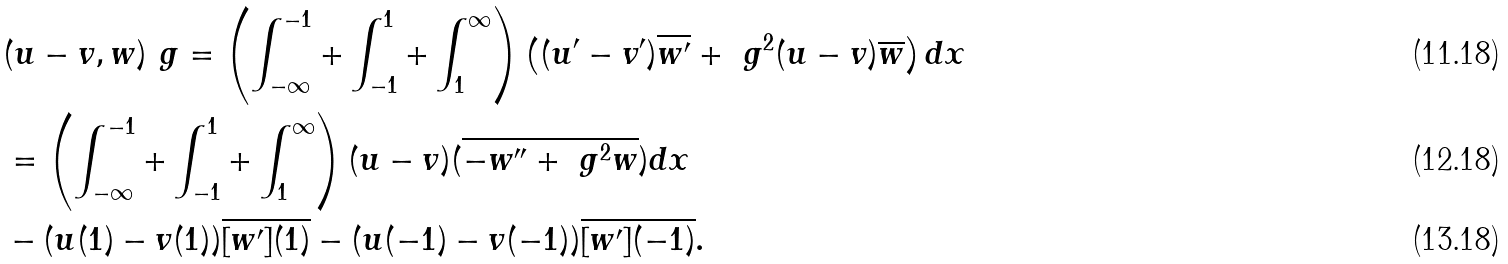Convert formula to latex. <formula><loc_0><loc_0><loc_500><loc_500>& ( u - v , w ) _ { \ } g = \left ( \int _ { - \infty } ^ { - 1 } + \int _ { - 1 } ^ { 1 } + \int _ { 1 } ^ { \infty } \right ) \left ( ( u ^ { \prime } - v ^ { \prime } ) \overline { w ^ { \prime } } + \ g ^ { 2 } ( u - v ) \overline { w } \right ) d x \\ & = \left ( \int _ { - \infty } ^ { - 1 } + \int _ { - 1 } ^ { 1 } + \int _ { 1 } ^ { \infty } \right ) ( u - v ) ( \overline { - w ^ { \prime \prime } + \ g ^ { 2 } { w } } ) d x \\ & - ( u ( 1 ) - v ( 1 ) ) \overline { [ w ^ { \prime } ] ( 1 ) } - ( u ( - 1 ) - v ( - 1 ) ) \overline { [ w ^ { \prime } ] ( - 1 ) } .</formula> 